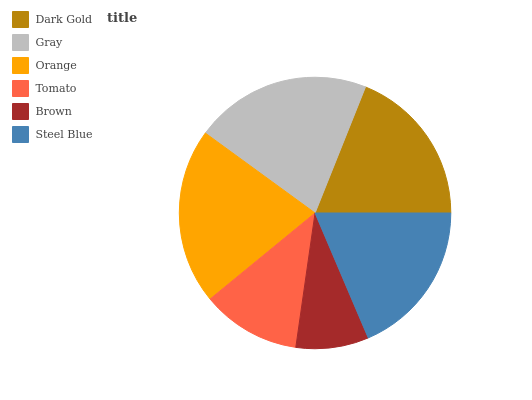Is Brown the minimum?
Answer yes or no. Yes. Is Gray the maximum?
Answer yes or no. Yes. Is Orange the minimum?
Answer yes or no. No. Is Orange the maximum?
Answer yes or no. No. Is Gray greater than Orange?
Answer yes or no. Yes. Is Orange less than Gray?
Answer yes or no. Yes. Is Orange greater than Gray?
Answer yes or no. No. Is Gray less than Orange?
Answer yes or no. No. Is Dark Gold the high median?
Answer yes or no. Yes. Is Steel Blue the low median?
Answer yes or no. Yes. Is Brown the high median?
Answer yes or no. No. Is Tomato the low median?
Answer yes or no. No. 